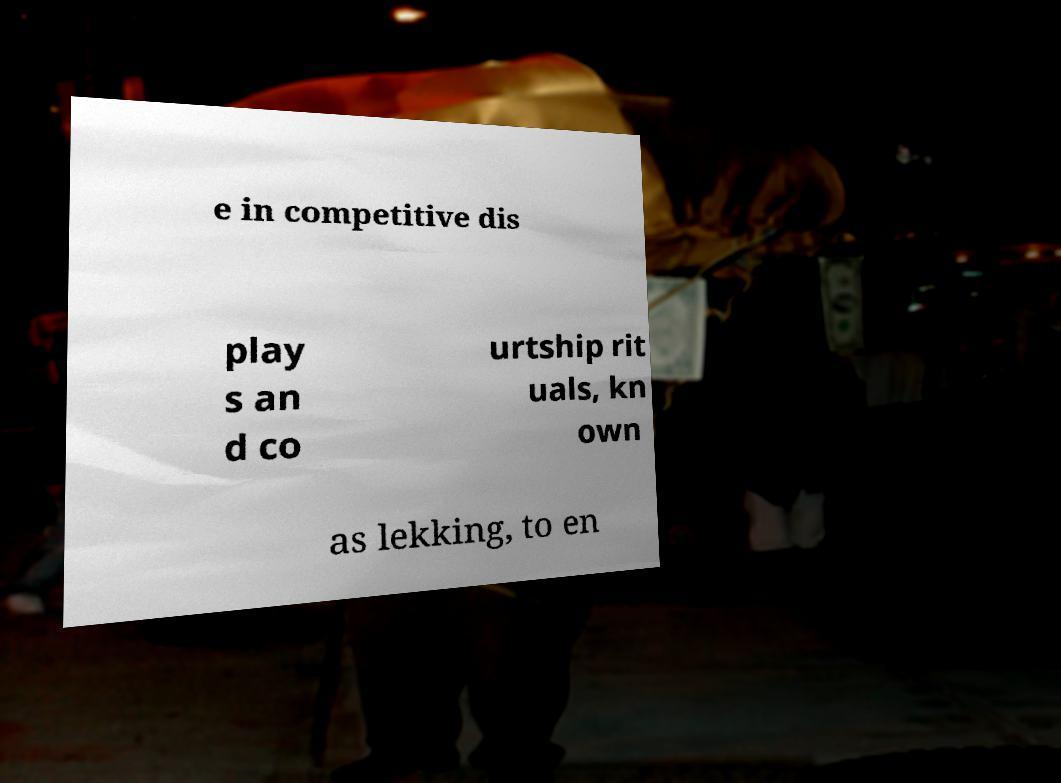Can you read and provide the text displayed in the image?This photo seems to have some interesting text. Can you extract and type it out for me? e in competitive dis play s an d co urtship rit uals, kn own as lekking, to en 